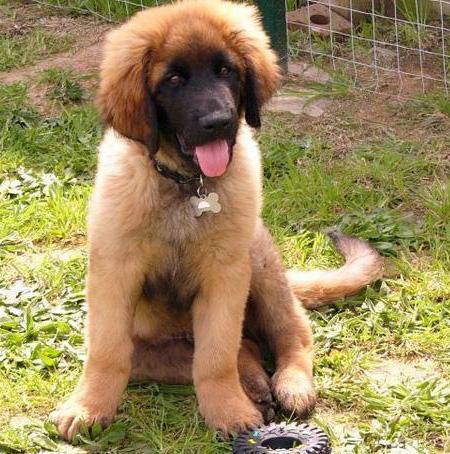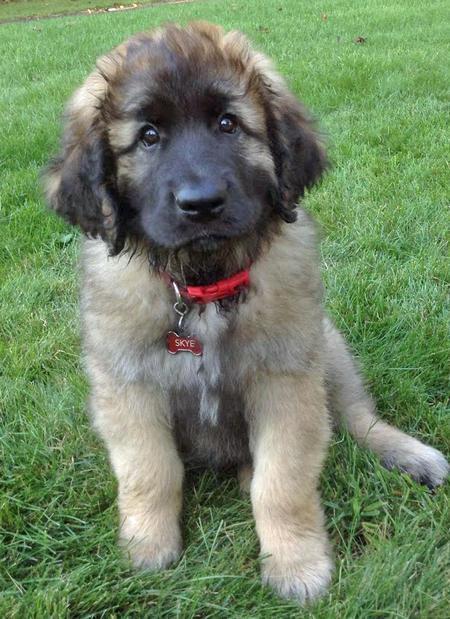The first image is the image on the left, the second image is the image on the right. Given the left and right images, does the statement "A human is petting a dog." hold true? Answer yes or no. No. The first image is the image on the left, the second image is the image on the right. Analyze the images presented: Is the assertion "An image includes a person behind a dog's head, with a hand near the side of the dog's head." valid? Answer yes or no. No. 